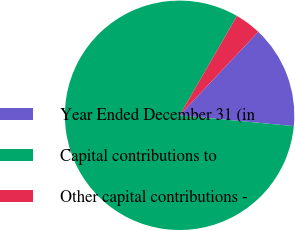<chart> <loc_0><loc_0><loc_500><loc_500><pie_chart><fcel>Year Ended December 31 (in<fcel>Capital contributions to<fcel>Other capital contributions -<nl><fcel>14.48%<fcel>81.83%<fcel>3.7%<nl></chart> 